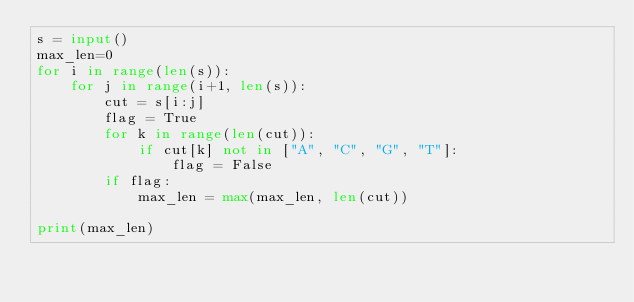Convert code to text. <code><loc_0><loc_0><loc_500><loc_500><_Python_>s = input()
max_len=0
for i in range(len(s)):
    for j in range(i+1, len(s)):
        cut = s[i:j]
        flag = True
        for k in range(len(cut)):
            if cut[k] not in ["A", "C", "G", "T"]:
                flag = False
        if flag:
            max_len = max(max_len, len(cut))

print(max_len)</code> 